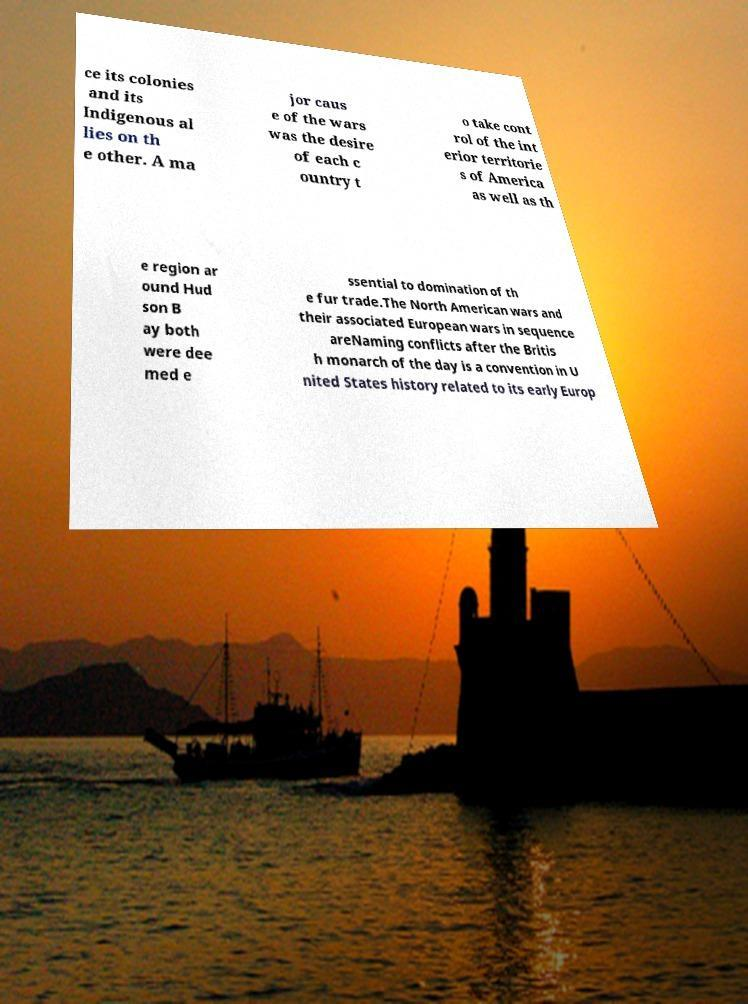Can you accurately transcribe the text from the provided image for me? ce its colonies and its Indigenous al lies on th e other. A ma jor caus e of the wars was the desire of each c ountry t o take cont rol of the int erior territorie s of America as well as th e region ar ound Hud son B ay both were dee med e ssential to domination of th e fur trade.The North American wars and their associated European wars in sequence areNaming conflicts after the Britis h monarch of the day is a convention in U nited States history related to its early Europ 